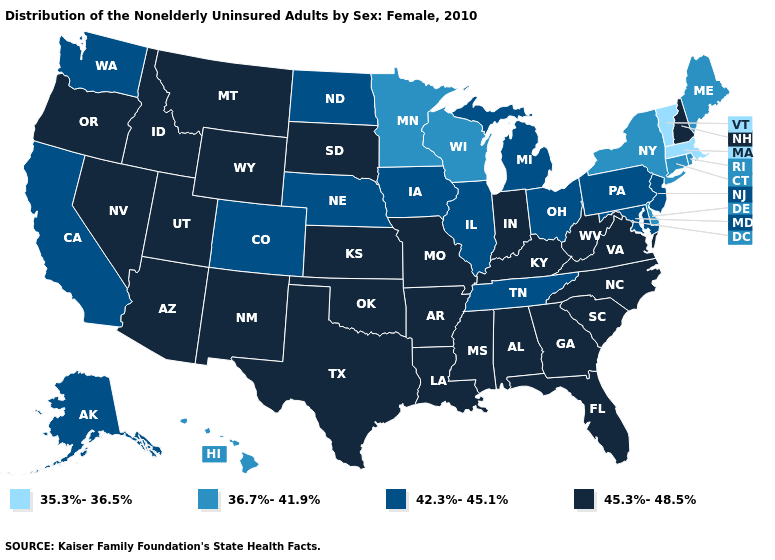Name the states that have a value in the range 35.3%-36.5%?
Quick response, please. Massachusetts, Vermont. What is the value of Tennessee?
Short answer required. 42.3%-45.1%. Name the states that have a value in the range 35.3%-36.5%?
Give a very brief answer. Massachusetts, Vermont. Name the states that have a value in the range 35.3%-36.5%?
Be succinct. Massachusetts, Vermont. Which states hav the highest value in the South?
Write a very short answer. Alabama, Arkansas, Florida, Georgia, Kentucky, Louisiana, Mississippi, North Carolina, Oklahoma, South Carolina, Texas, Virginia, West Virginia. Name the states that have a value in the range 45.3%-48.5%?
Short answer required. Alabama, Arizona, Arkansas, Florida, Georgia, Idaho, Indiana, Kansas, Kentucky, Louisiana, Mississippi, Missouri, Montana, Nevada, New Hampshire, New Mexico, North Carolina, Oklahoma, Oregon, South Carolina, South Dakota, Texas, Utah, Virginia, West Virginia, Wyoming. What is the value of Montana?
Quick response, please. 45.3%-48.5%. What is the value of Rhode Island?
Write a very short answer. 36.7%-41.9%. Which states hav the highest value in the Northeast?
Give a very brief answer. New Hampshire. Name the states that have a value in the range 42.3%-45.1%?
Be succinct. Alaska, California, Colorado, Illinois, Iowa, Maryland, Michigan, Nebraska, New Jersey, North Dakota, Ohio, Pennsylvania, Tennessee, Washington. What is the value of Ohio?
Quick response, please. 42.3%-45.1%. What is the lowest value in the USA?
Concise answer only. 35.3%-36.5%. Name the states that have a value in the range 35.3%-36.5%?
Write a very short answer. Massachusetts, Vermont. What is the lowest value in the USA?
Be succinct. 35.3%-36.5%. How many symbols are there in the legend?
Be succinct. 4. 